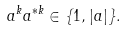<formula> <loc_0><loc_0><loc_500><loc_500>a ^ { k } a ^ { * k } \in \{ 1 , | a | \} .</formula> 